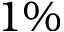<formula> <loc_0><loc_0><loc_500><loc_500>1 \%</formula> 